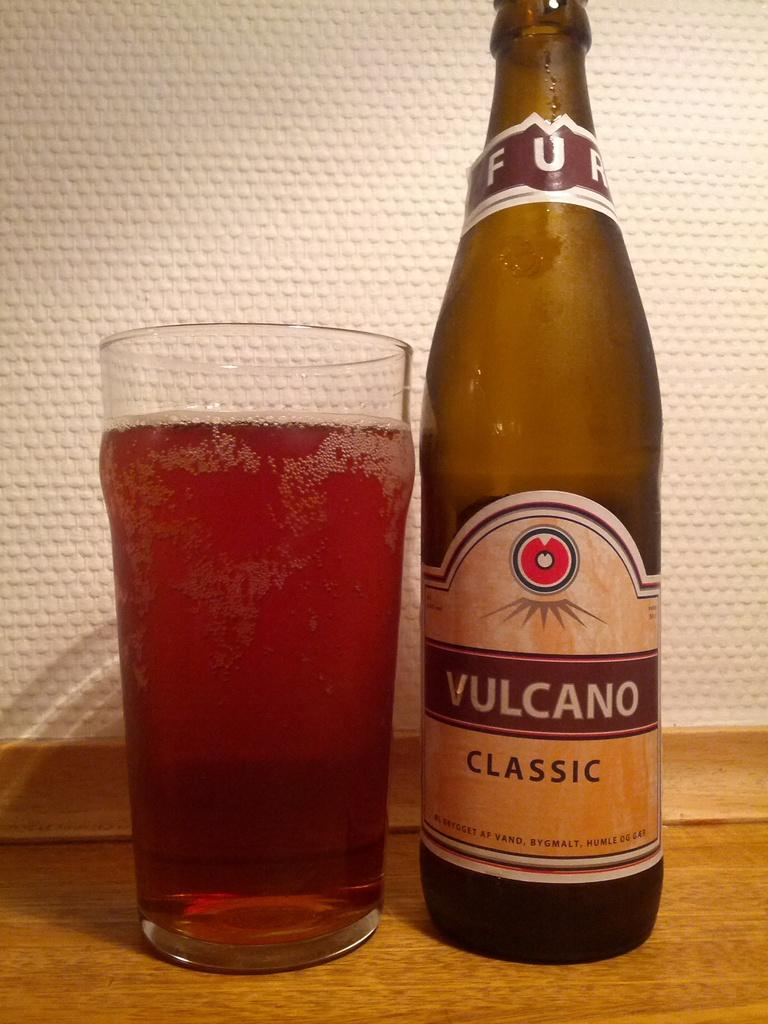<image>
Create a compact narrative representing the image presented. A mostly empty bottle of Vulcano Classic sits next to a full glass. 